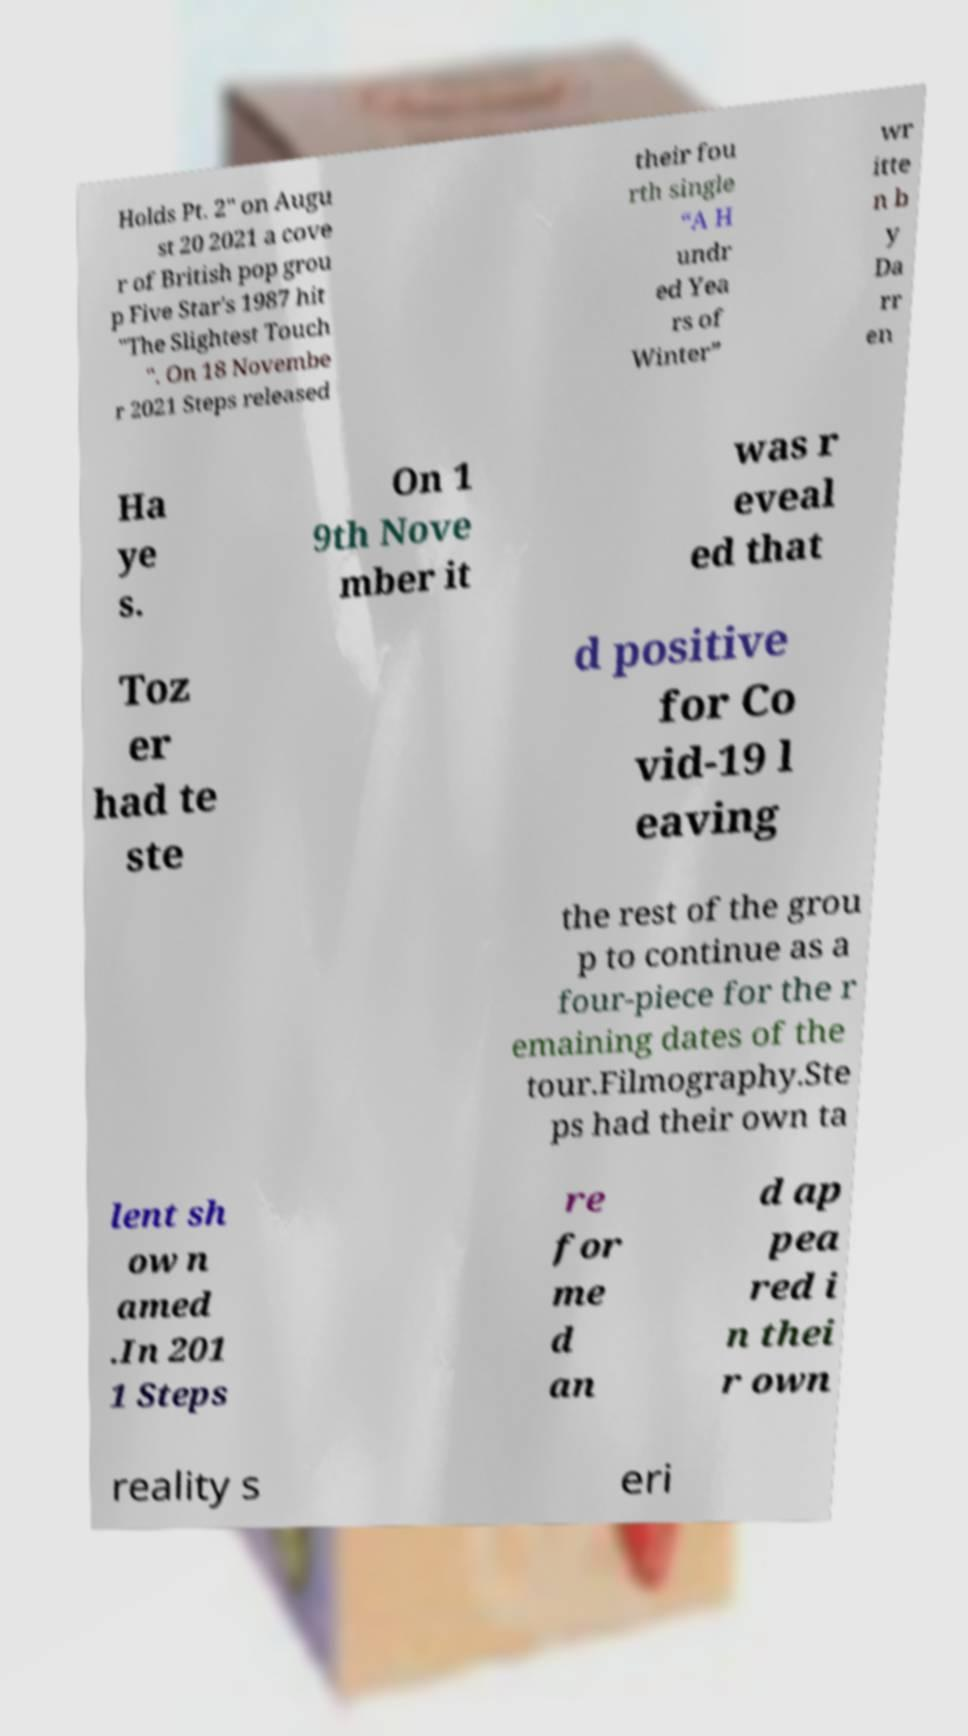I need the written content from this picture converted into text. Can you do that? Holds Pt. 2" on Augu st 20 2021 a cove r of British pop grou p Five Star's 1987 hit "The Slightest Touch ". On 18 Novembe r 2021 Steps released their fou rth single “A H undr ed Yea rs of Winter” wr itte n b y Da rr en Ha ye s. On 1 9th Nove mber it was r eveal ed that Toz er had te ste d positive for Co vid-19 l eaving the rest of the grou p to continue as a four-piece for the r emaining dates of the tour.Filmography.Ste ps had their own ta lent sh ow n amed .In 201 1 Steps re for me d an d ap pea red i n thei r own reality s eri 